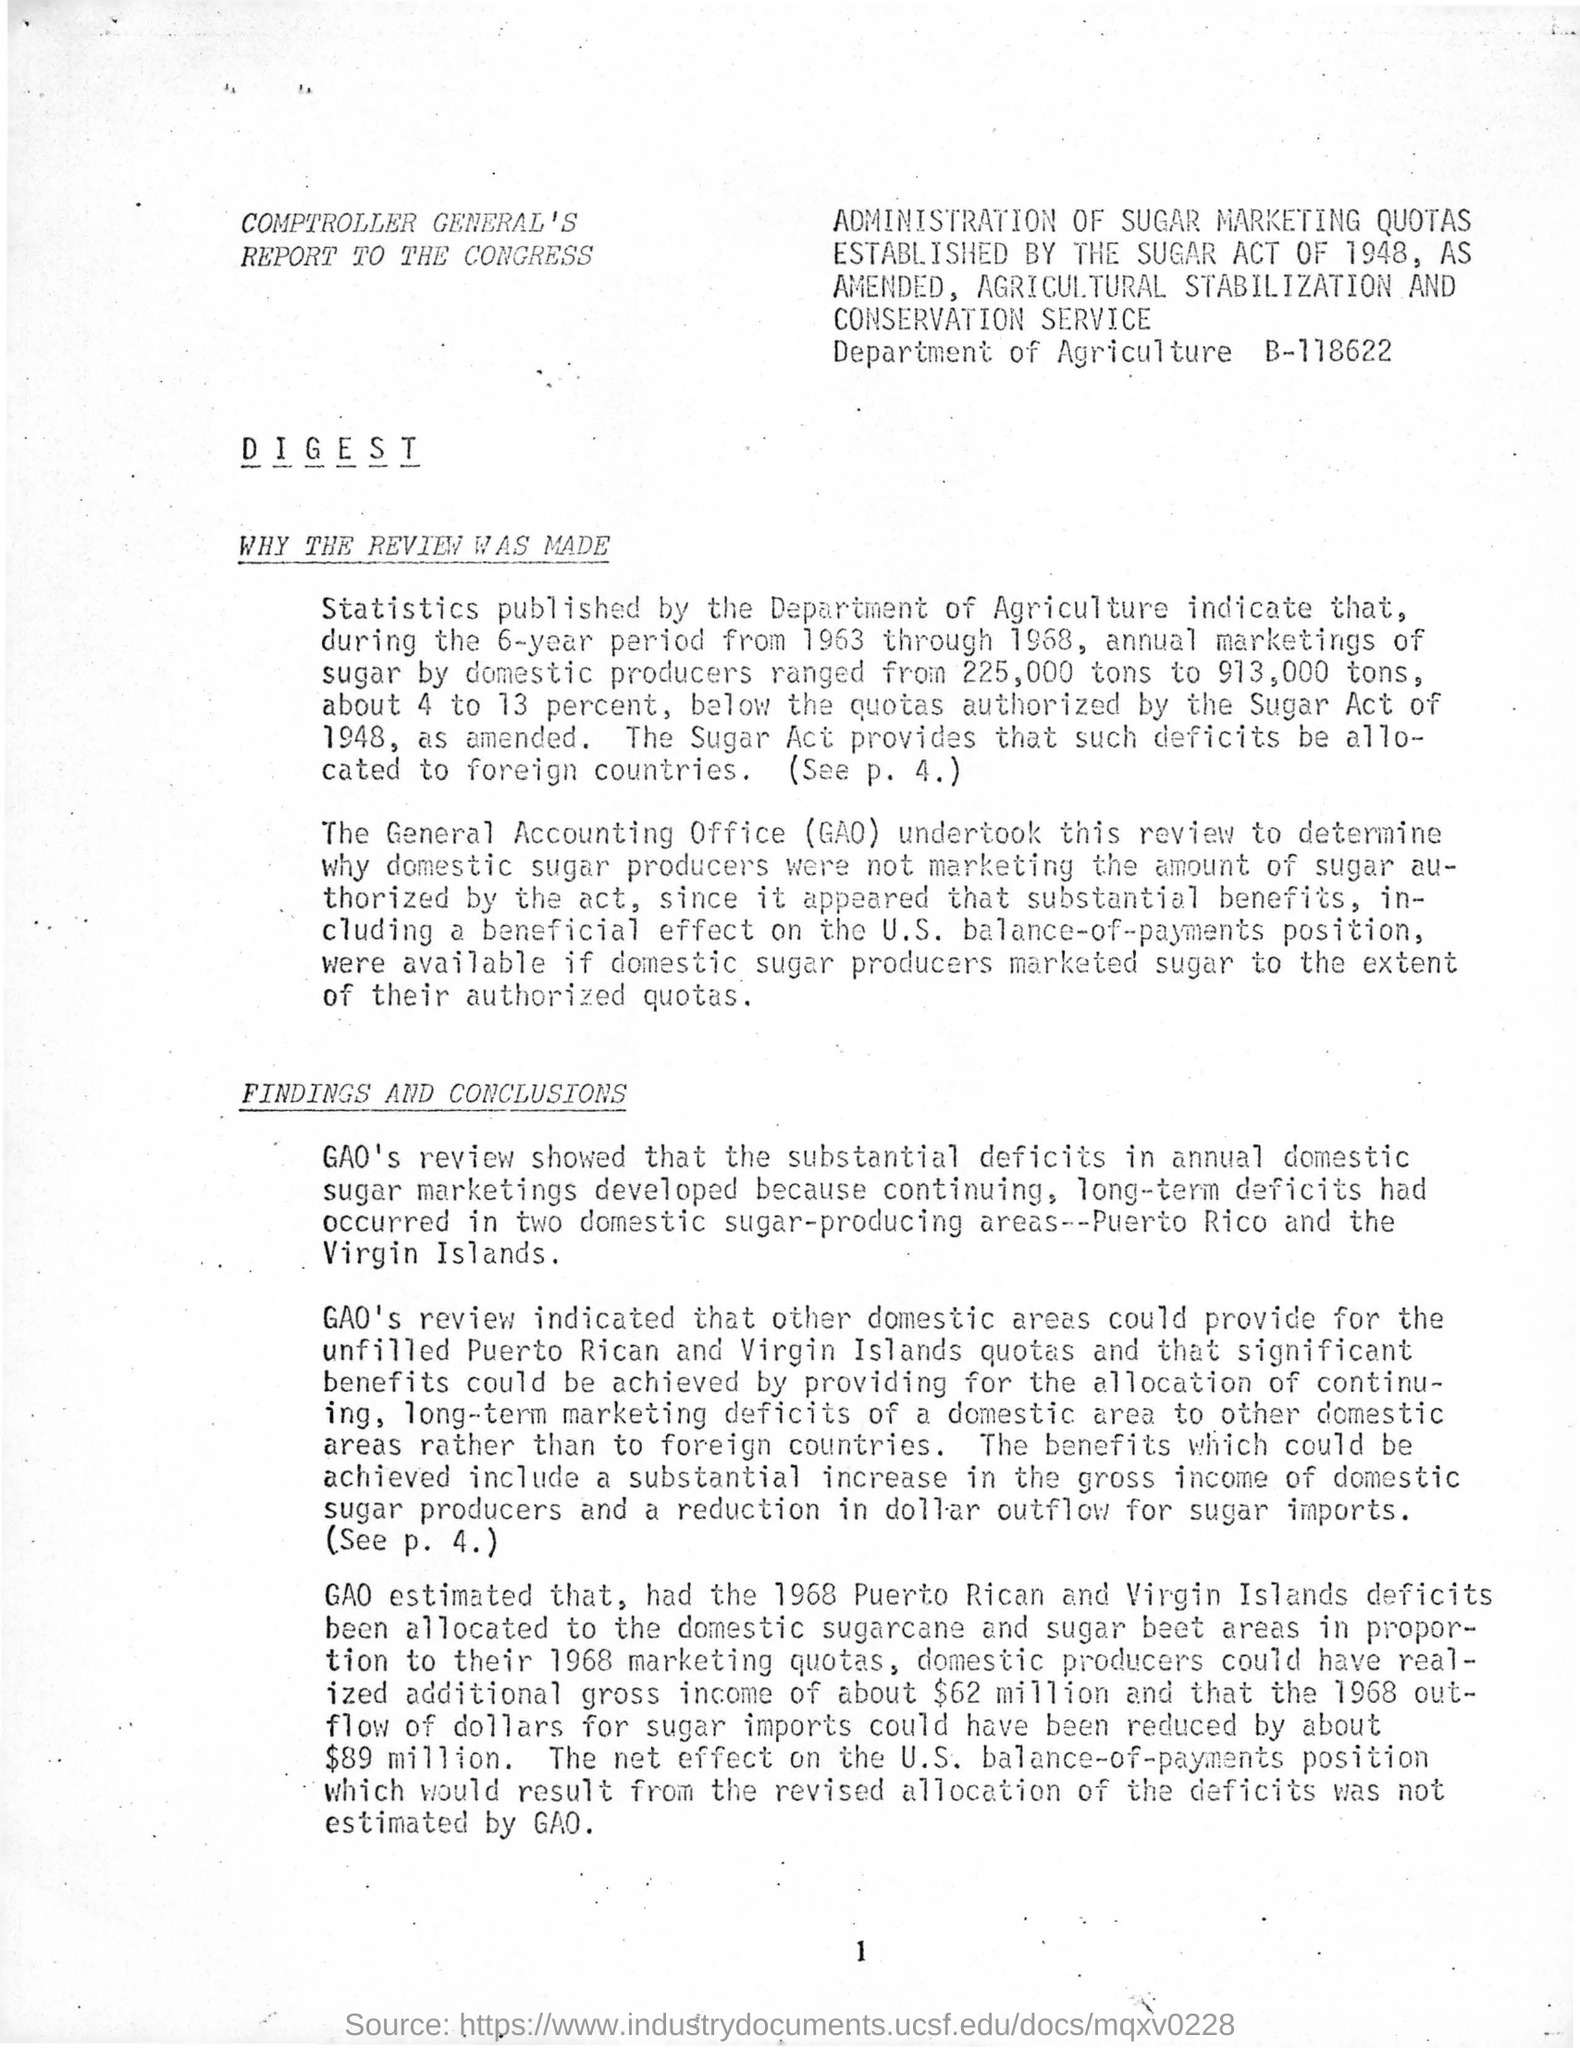What is the Page Number?
Make the answer very short. 1. 